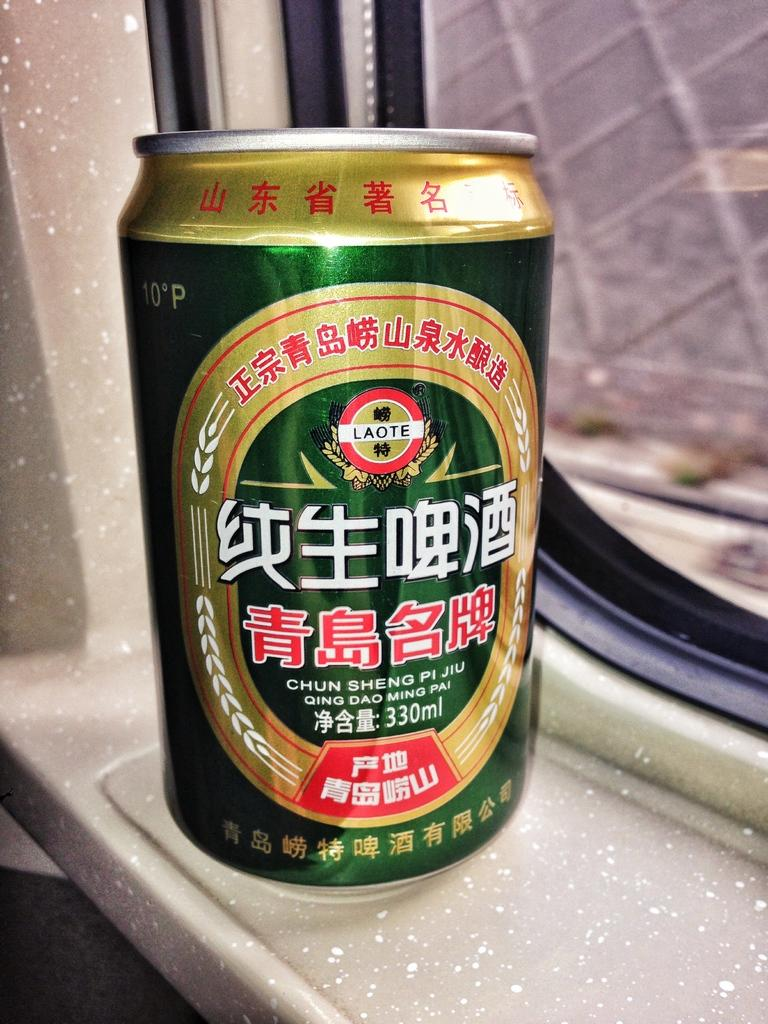<image>
Present a compact description of the photo's key features. a can that says chun sheng on it 